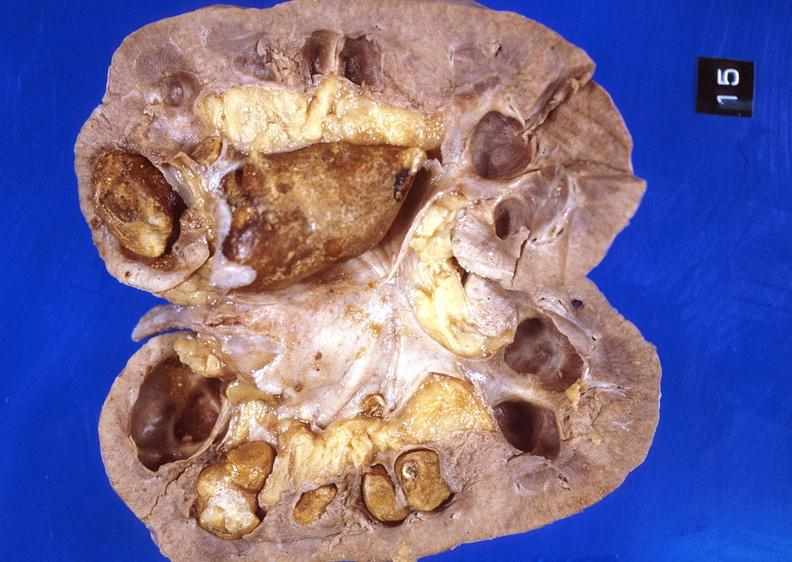what does this image show?
Answer the question using a single word or phrase. Kidney 